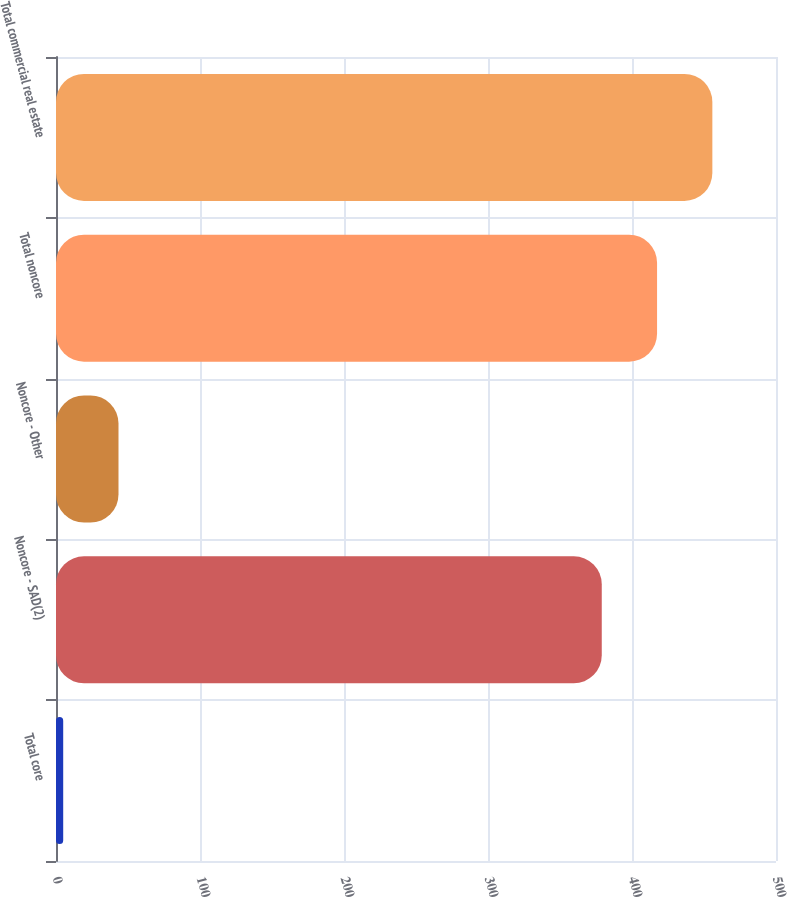Convert chart. <chart><loc_0><loc_0><loc_500><loc_500><bar_chart><fcel>Total core<fcel>Noncore - SAD(2)<fcel>Noncore - Other<fcel>Total noncore<fcel>Total commercial real estate<nl><fcel>5<fcel>379<fcel>43.4<fcel>417.4<fcel>455.8<nl></chart> 